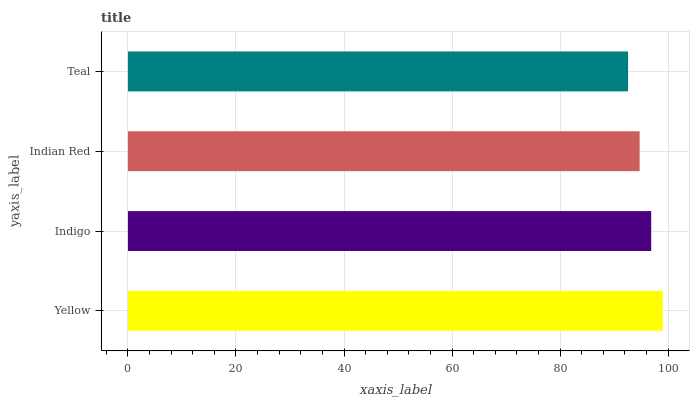Is Teal the minimum?
Answer yes or no. Yes. Is Yellow the maximum?
Answer yes or no. Yes. Is Indigo the minimum?
Answer yes or no. No. Is Indigo the maximum?
Answer yes or no. No. Is Yellow greater than Indigo?
Answer yes or no. Yes. Is Indigo less than Yellow?
Answer yes or no. Yes. Is Indigo greater than Yellow?
Answer yes or no. No. Is Yellow less than Indigo?
Answer yes or no. No. Is Indigo the high median?
Answer yes or no. Yes. Is Indian Red the low median?
Answer yes or no. Yes. Is Teal the high median?
Answer yes or no. No. Is Yellow the low median?
Answer yes or no. No. 